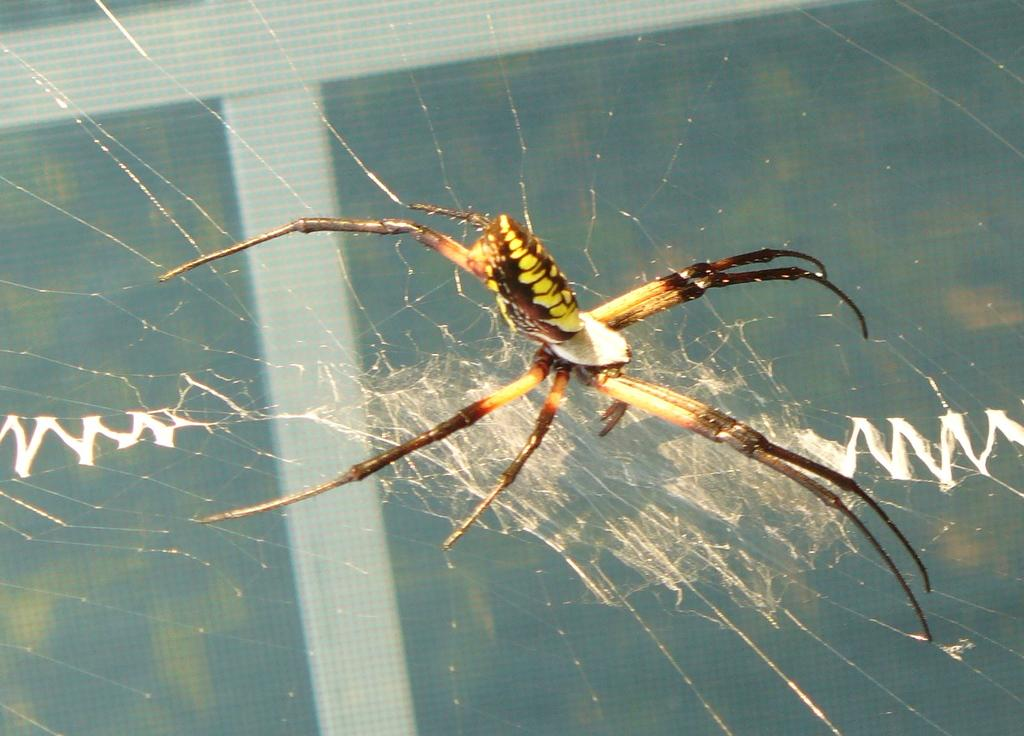What is the main subject of the image? The main subject of the image is a spider. Where is the spider located in the image? The spider is in a web. What type of structure does the coach use to store shoes in the image? There is no coach or shoes present in the image; it only features a spider in a web. 